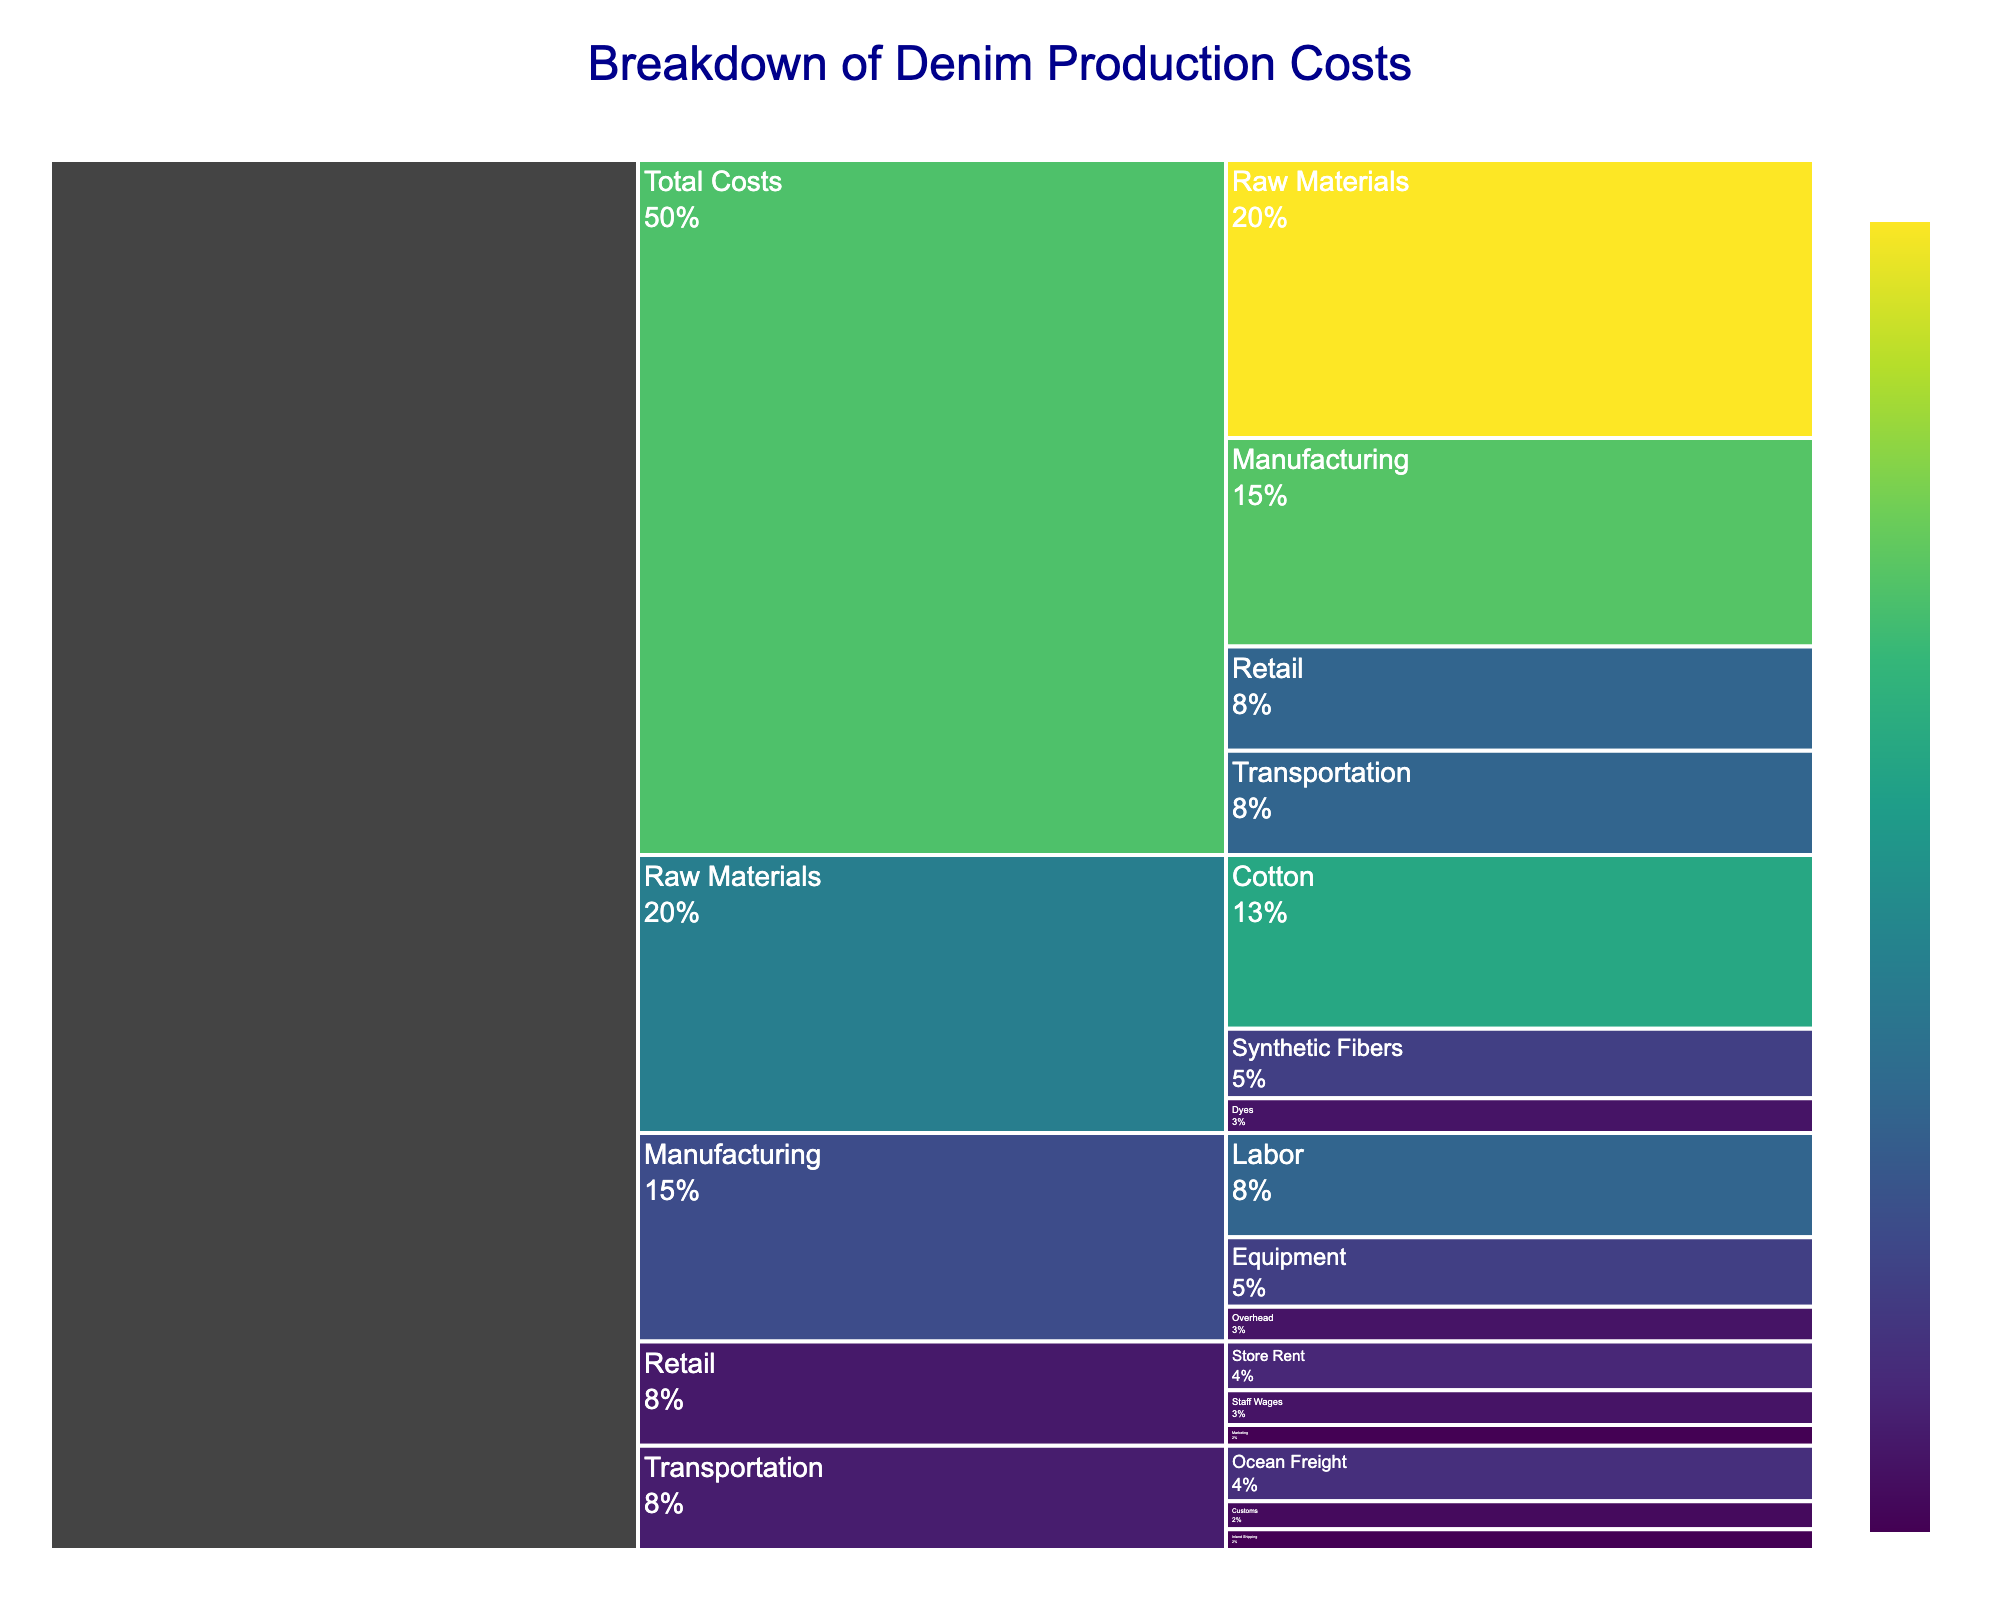What's the title of the figure? Look at the top of the figure where the title is usually placed. The title of the chart will describe the main context or purpose of the visualization.
Answer: Breakdown of Denim Production Costs Which category has the highest cost? Examine the top level of the icicle chart where the main categories are listed. Compare the cost values associated with each category.
Answer: Raw Materials What percentage of the total costs does the Transportation category represent? Find the Transportation category in the chart. From the text information on the visualization, note the percentage shown for Transportation.
Answer: 15% How does the cost of Customs compare to Inland Shipping? Look under the Transportation category for the subcategories Customs and Inland Shipping. Compare their cost values.
Answer: Customs costs more than Inland Shipping What is the sum of costs for all subcategories under Raw Materials? Locate the subcategories under Raw Materials, which are Cotton, Synthetic Fibers, and Dyes. Add up their costs: 25 (Cotton) + 10 (Synthetic Fibers) + 5 (Dyes).
Answer: 40 How do the combined costs of Retail subcategories compare to the costs of Manufacturing? Sum the costs of subcategories under Retail: 7 (Store Rent) + 5 (Staff Wages) + 3 (Marketing) = 15. Compare this sum (15) to the total Manufacturing cost (30).
Answer: Retail subcategories cost less than Manufacturing Which subcategory under Manufacturing has the lowest cost? Identify subcategories under Manufacturing: Labor, Equipment, Overhead. Compare their costs to find the smallest value.
Answer: Overhead What is the total cost of Equipment and Store Rent combined? Find the costs for Equipment under Manufacturing (10) and Store Rent under Retail (7). Add these two values together: 10 + 7 = 17.
Answer: 17 What percentage of total Raw Materials costs is allocated to Cotton? First, note the cost for Cotton under Raw Materials (25). Then, consider the total Raw Materials costs (40). Calculate the percentage: (25 / 40) * 100%.
Answer: 62.5% Which has a higher cost: Synthetic Fibers or Marketing? Locate the cost for Synthetic Fibers under Raw Materials (10) and the cost for Marketing under Retail (3). Compare these values.
Answer: Synthetic Fibers 